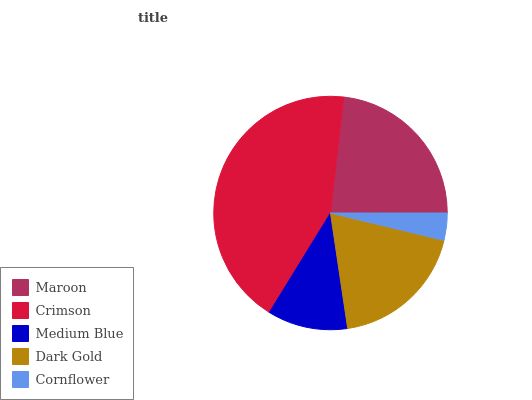Is Cornflower the minimum?
Answer yes or no. Yes. Is Crimson the maximum?
Answer yes or no. Yes. Is Medium Blue the minimum?
Answer yes or no. No. Is Medium Blue the maximum?
Answer yes or no. No. Is Crimson greater than Medium Blue?
Answer yes or no. Yes. Is Medium Blue less than Crimson?
Answer yes or no. Yes. Is Medium Blue greater than Crimson?
Answer yes or no. No. Is Crimson less than Medium Blue?
Answer yes or no. No. Is Dark Gold the high median?
Answer yes or no. Yes. Is Dark Gold the low median?
Answer yes or no. Yes. Is Medium Blue the high median?
Answer yes or no. No. Is Crimson the low median?
Answer yes or no. No. 